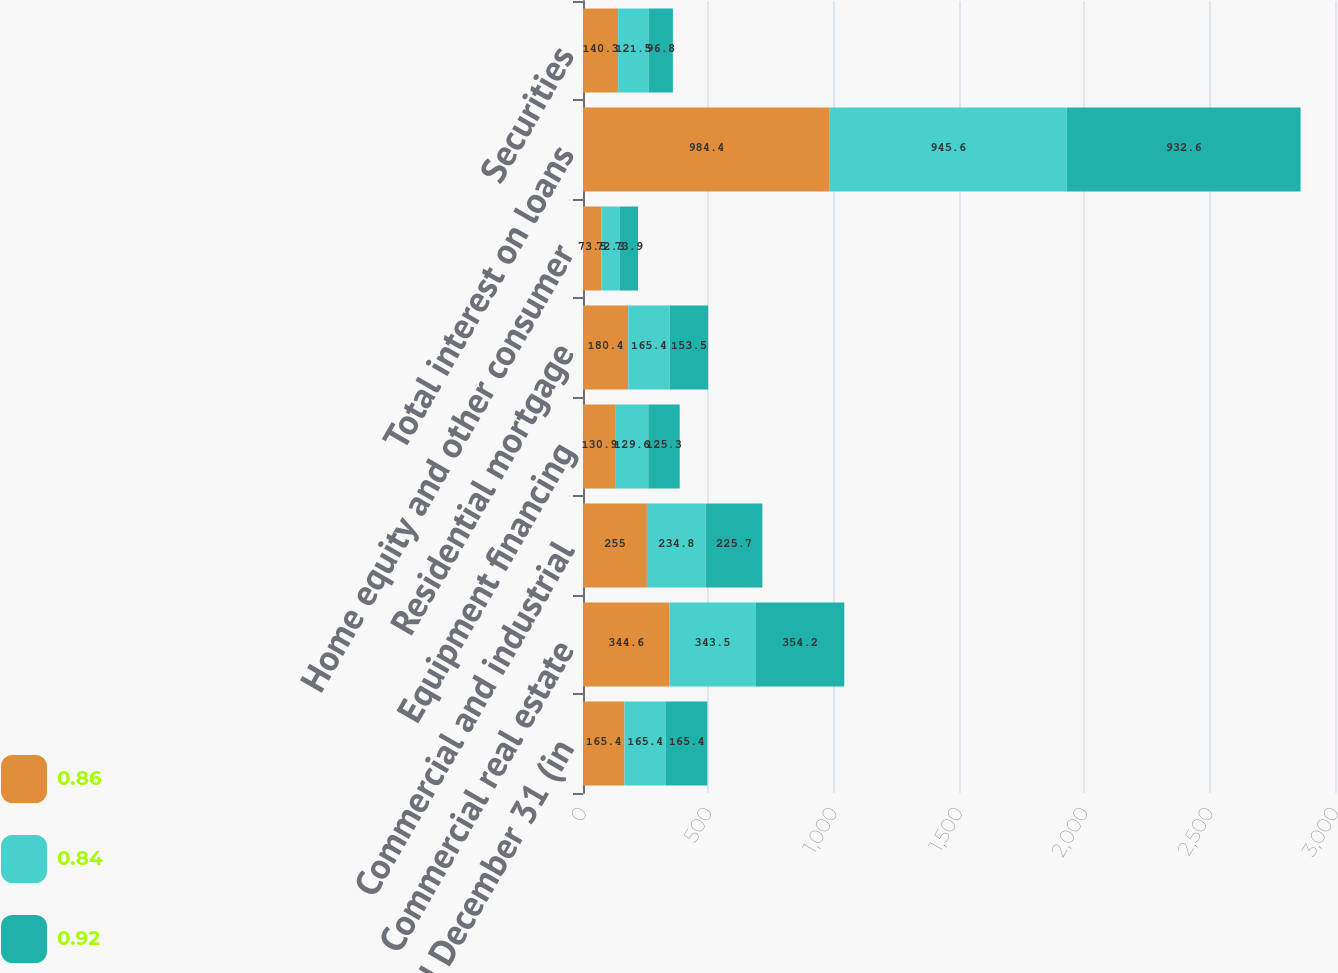Convert chart. <chart><loc_0><loc_0><loc_500><loc_500><stacked_bar_chart><ecel><fcel>Years ended December 31 (in<fcel>Commercial real estate<fcel>Commercial and industrial<fcel>Equipment financing<fcel>Residential mortgage<fcel>Home equity and other consumer<fcel>Total interest on loans<fcel>Securities<nl><fcel>0.86<fcel>165.4<fcel>344.6<fcel>255<fcel>130.9<fcel>180.4<fcel>73.5<fcel>984.4<fcel>140.3<nl><fcel>0.84<fcel>165.4<fcel>343.5<fcel>234.8<fcel>129.6<fcel>165.4<fcel>72.3<fcel>945.6<fcel>121.5<nl><fcel>0.92<fcel>165.4<fcel>354.2<fcel>225.7<fcel>125.3<fcel>153.5<fcel>73.9<fcel>932.6<fcel>96.8<nl></chart> 